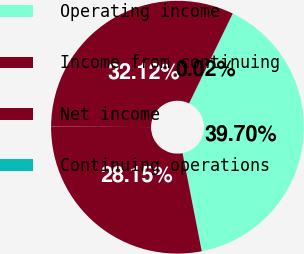Convert chart to OTSL. <chart><loc_0><loc_0><loc_500><loc_500><pie_chart><fcel>Operating income<fcel>Income from continuing<fcel>Net income<fcel>Continuing operations<nl><fcel>39.7%<fcel>28.15%<fcel>32.12%<fcel>0.02%<nl></chart> 